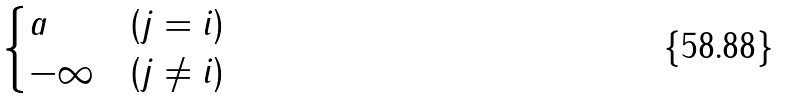Convert formula to latex. <formula><loc_0><loc_0><loc_500><loc_500>\begin{cases} a & ( j = i ) \\ - \infty & ( j \neq i ) \end{cases}</formula> 